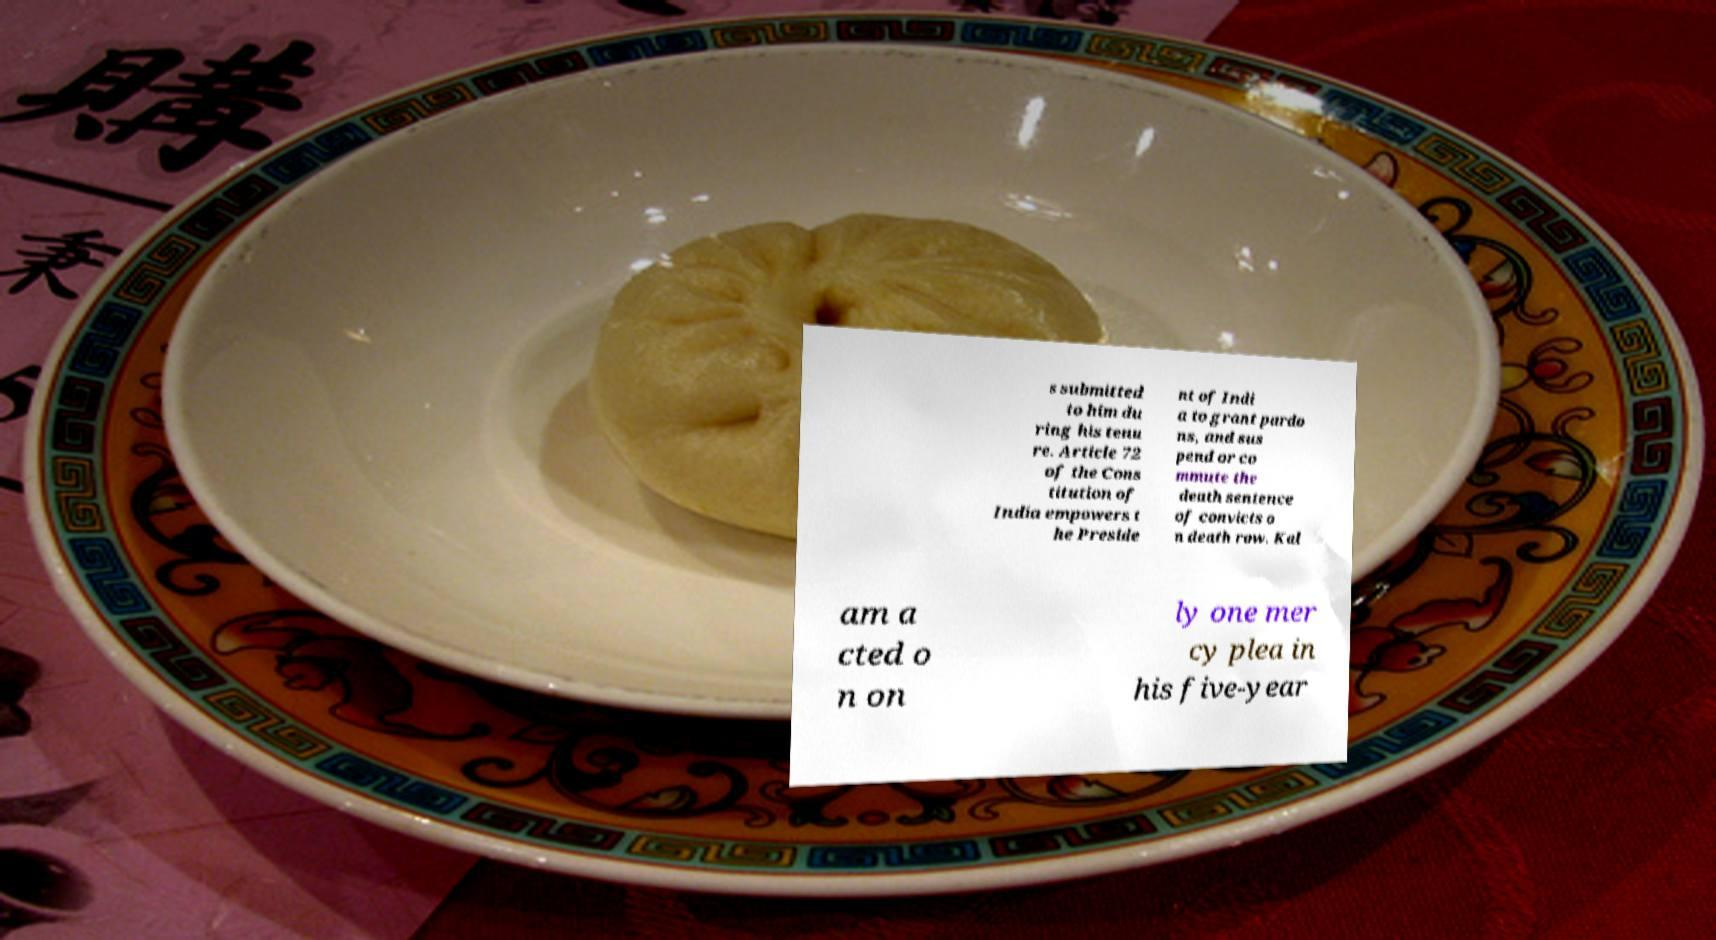Can you read and provide the text displayed in the image?This photo seems to have some interesting text. Can you extract and type it out for me? s submitted to him du ring his tenu re. Article 72 of the Cons titution of India empowers t he Preside nt of Indi a to grant pardo ns, and sus pend or co mmute the death sentence of convicts o n death row. Kal am a cted o n on ly one mer cy plea in his five-year 